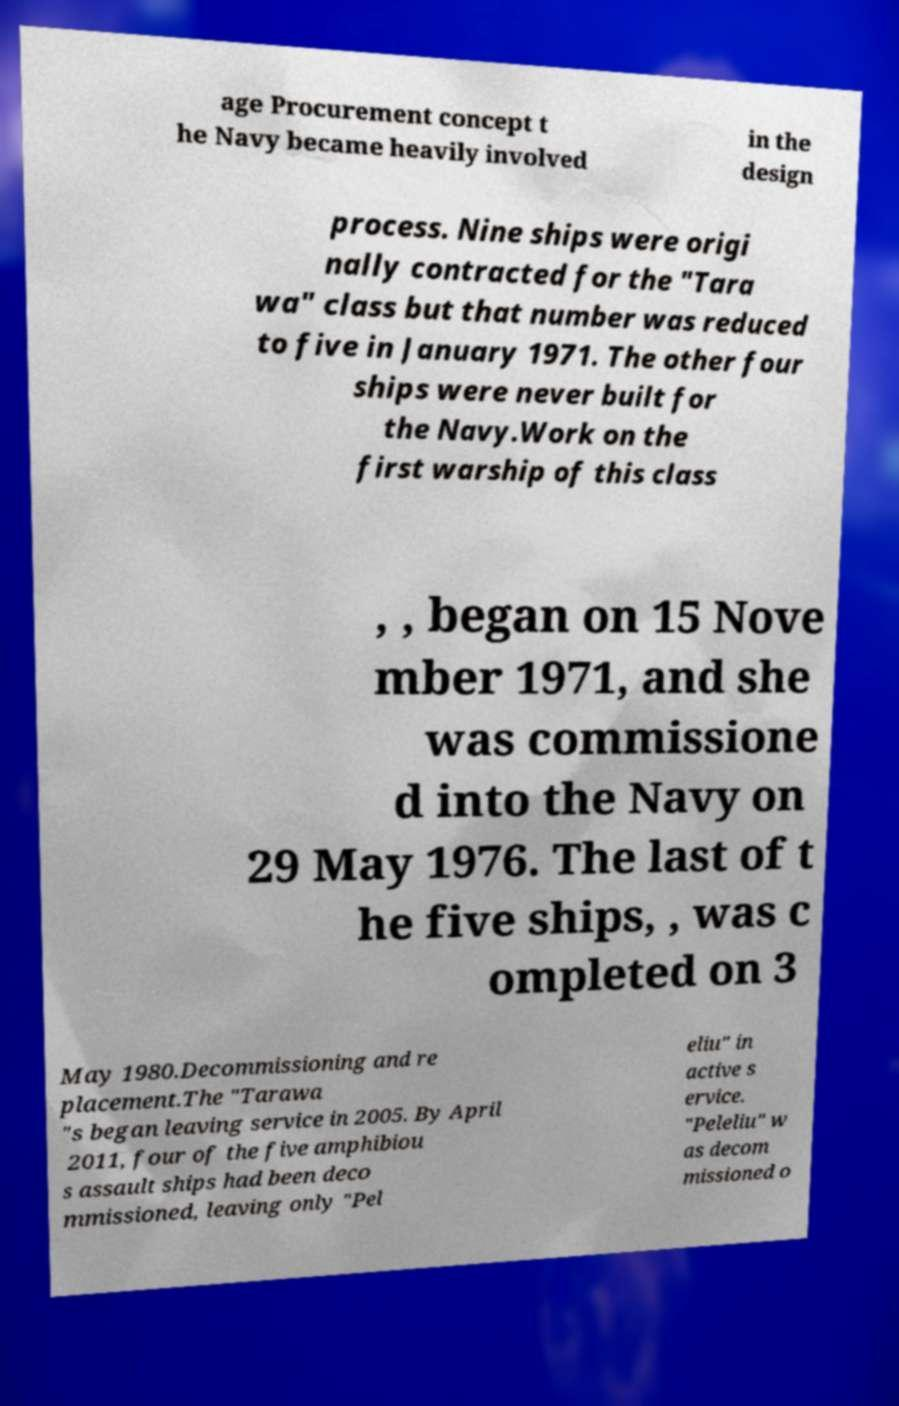Could you assist in decoding the text presented in this image and type it out clearly? age Procurement concept t he Navy became heavily involved in the design process. Nine ships were origi nally contracted for the "Tara wa" class but that number was reduced to five in January 1971. The other four ships were never built for the Navy.Work on the first warship of this class , , began on 15 Nove mber 1971, and she was commissione d into the Navy on 29 May 1976. The last of t he five ships, , was c ompleted on 3 May 1980.Decommissioning and re placement.The "Tarawa "s began leaving service in 2005. By April 2011, four of the five amphibiou s assault ships had been deco mmissioned, leaving only "Pel eliu" in active s ervice. "Peleliu" w as decom missioned o 